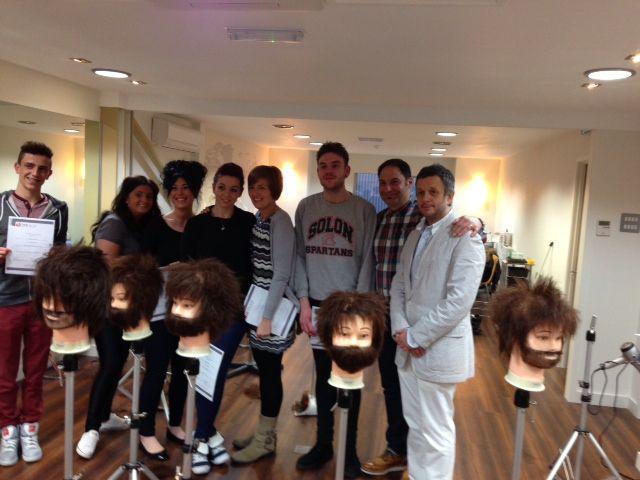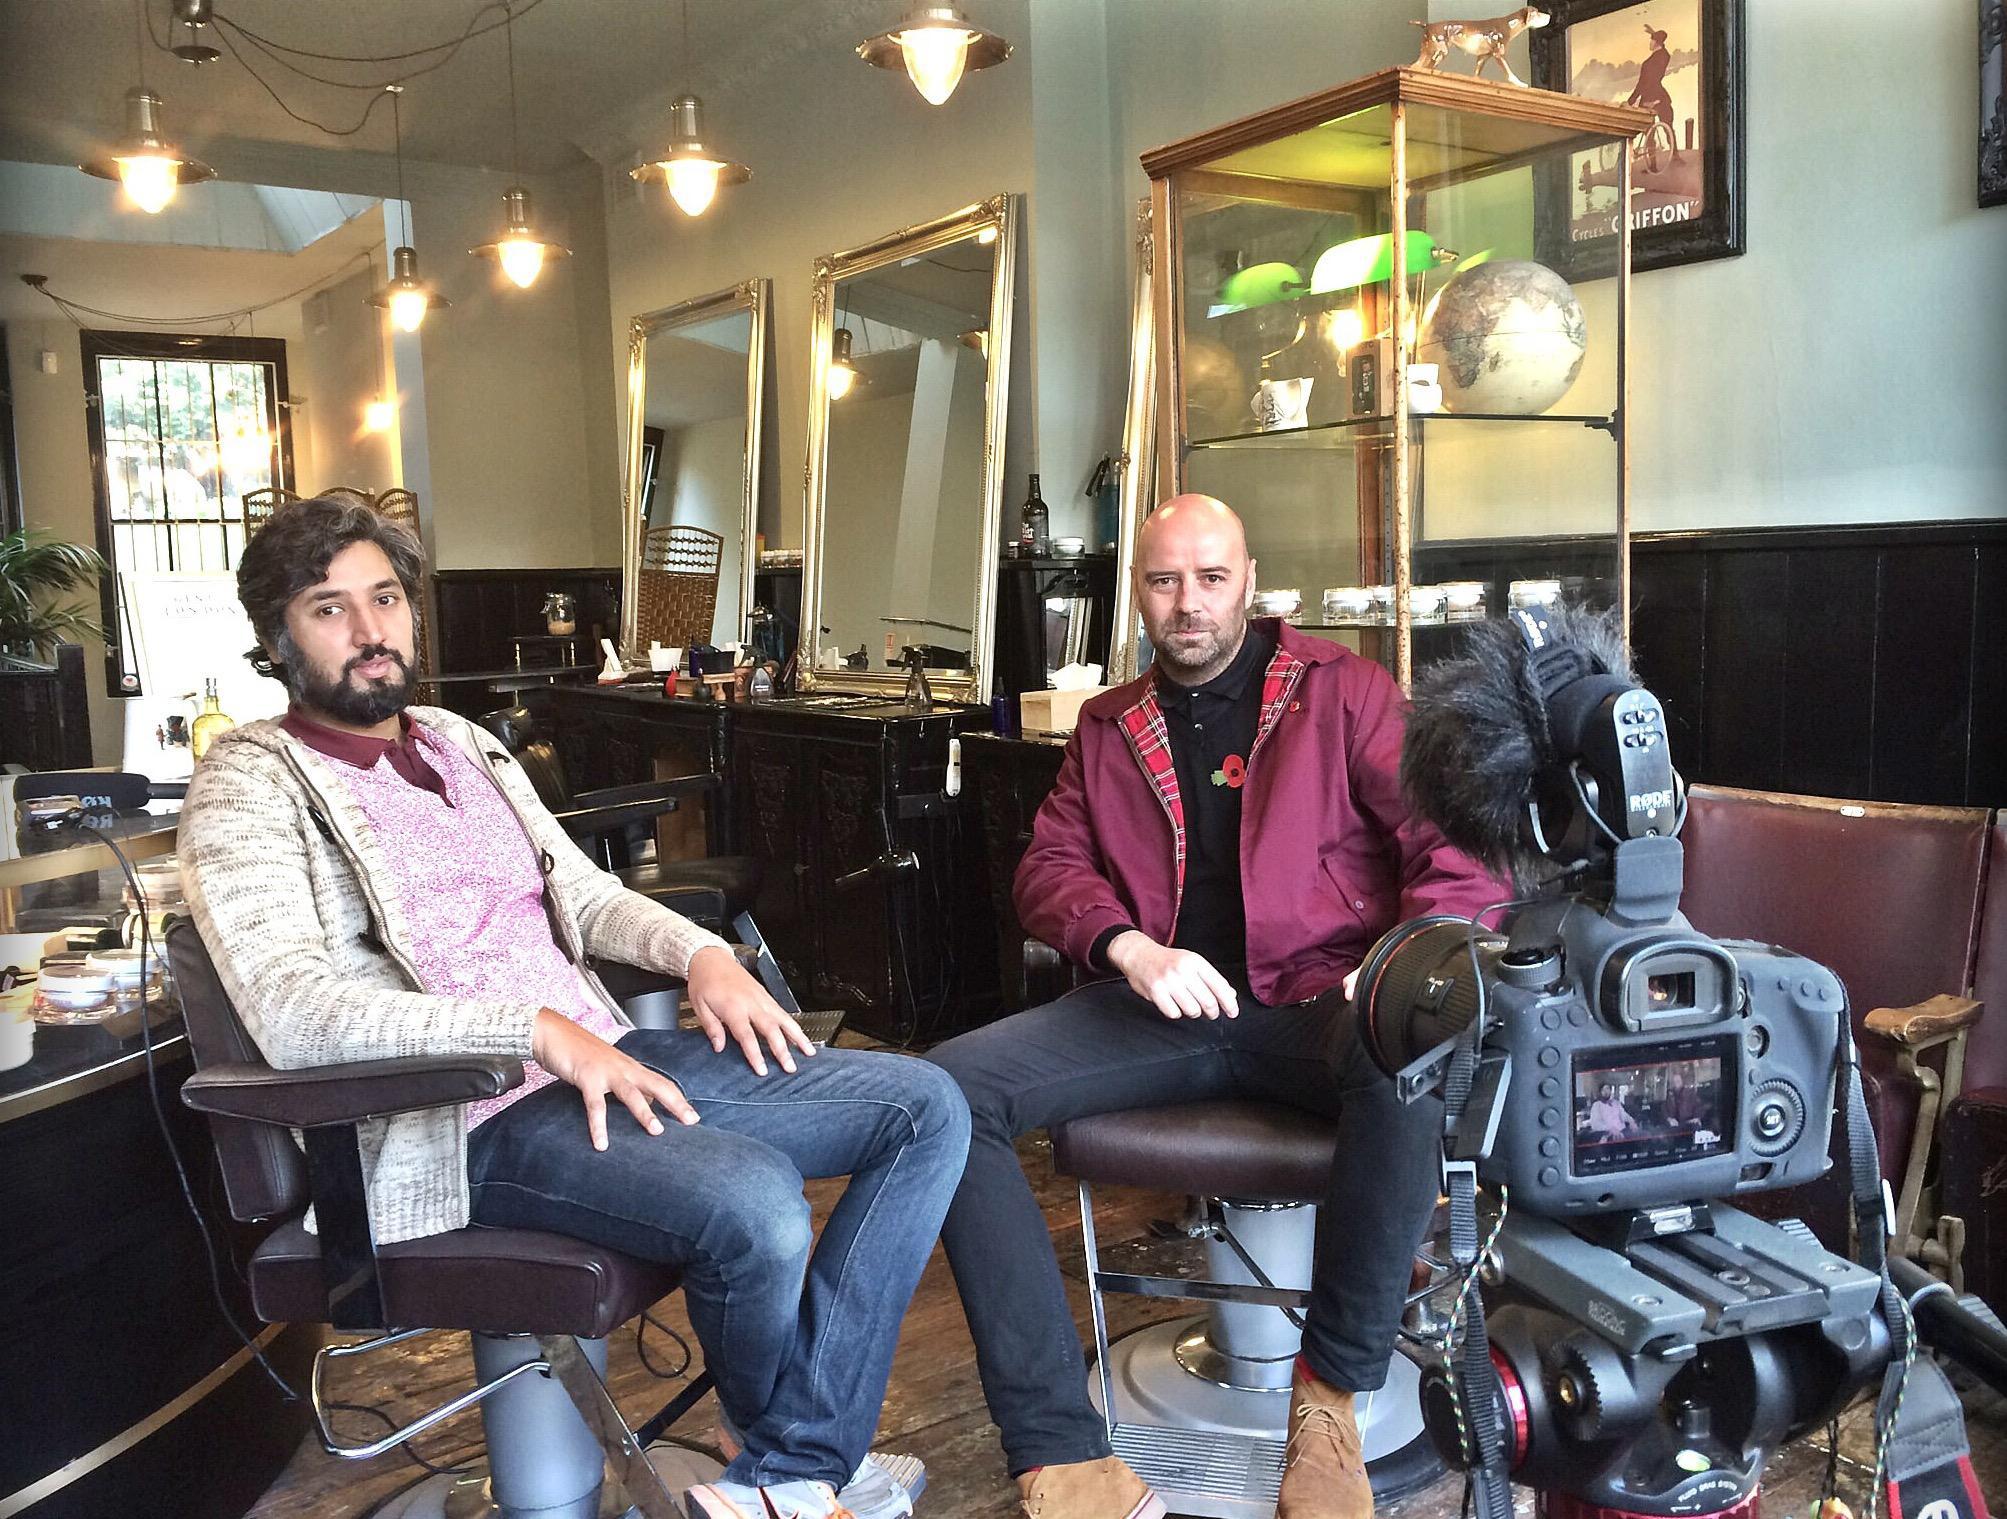The first image is the image on the left, the second image is the image on the right. Examine the images to the left and right. Is the description "In at least one image there are two visible faces in the barbershop." accurate? Answer yes or no. Yes. The first image is the image on the left, the second image is the image on the right. For the images displayed, is the sentence "There are exactly two people in the left image." factually correct? Answer yes or no. No. 